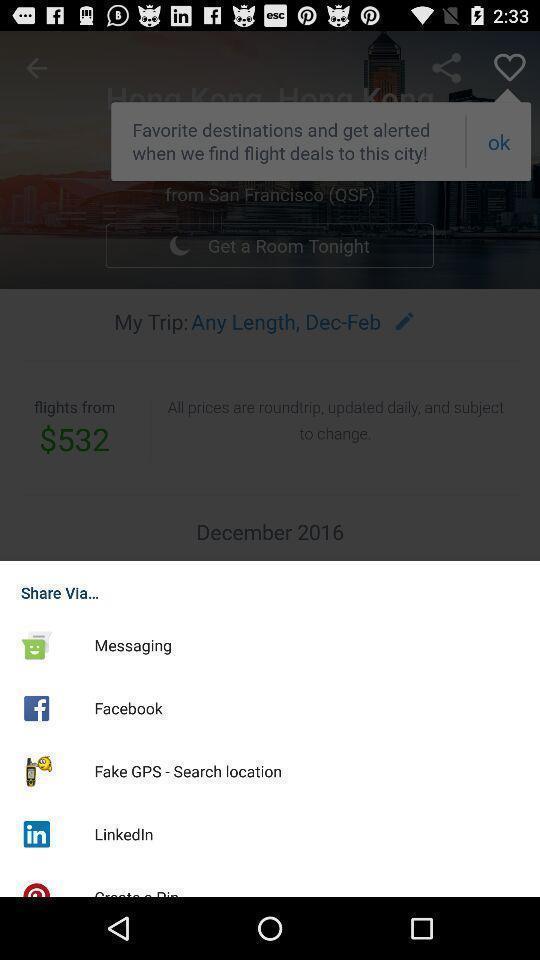Explain what's happening in this screen capture. Share page to select through which app to complete action. 